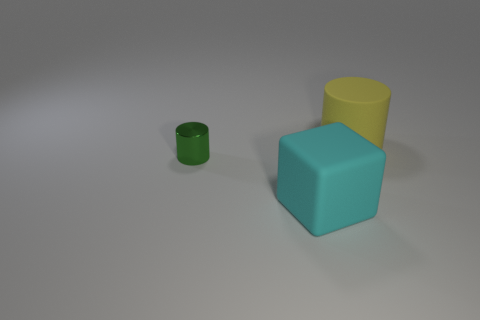Add 1 small green metal cylinders. How many objects exist? 4 Subtract all big yellow matte cylinders. Subtract all big red cylinders. How many objects are left? 2 Add 1 big objects. How many big objects are left? 3 Add 2 large objects. How many large objects exist? 4 Subtract 0 brown blocks. How many objects are left? 3 Subtract all cubes. How many objects are left? 2 